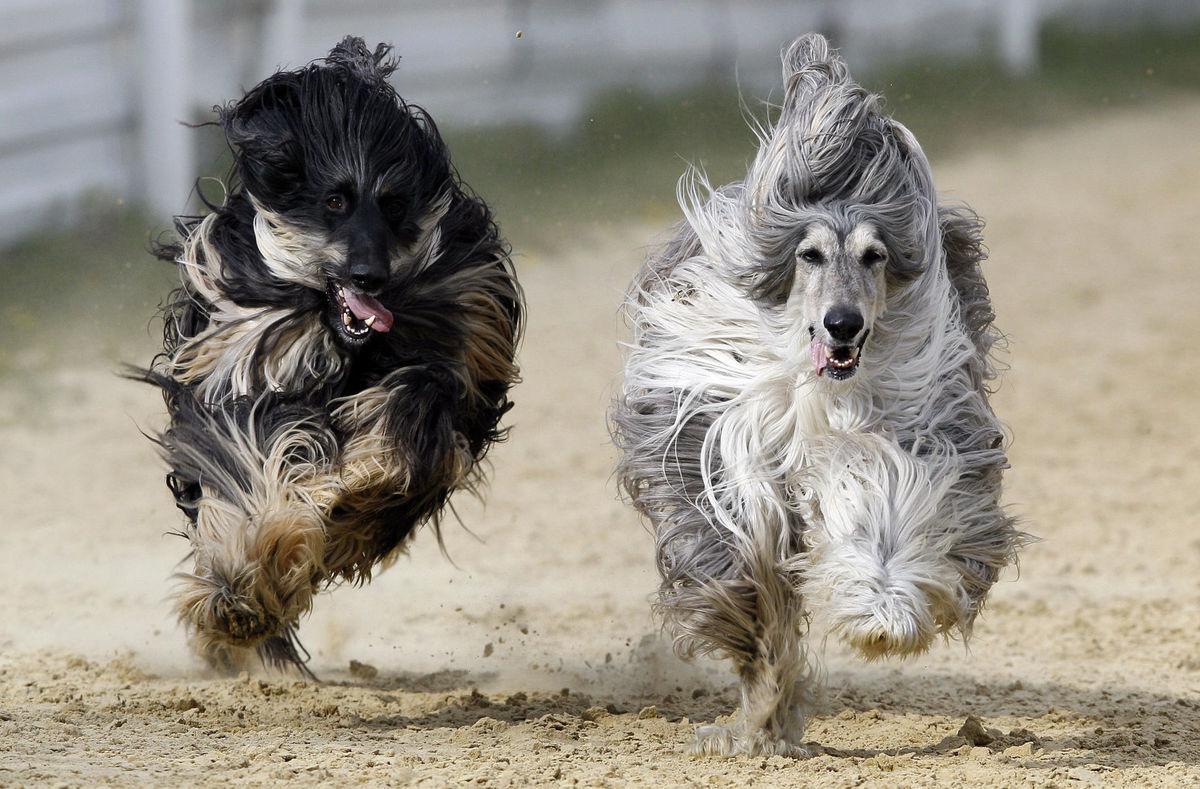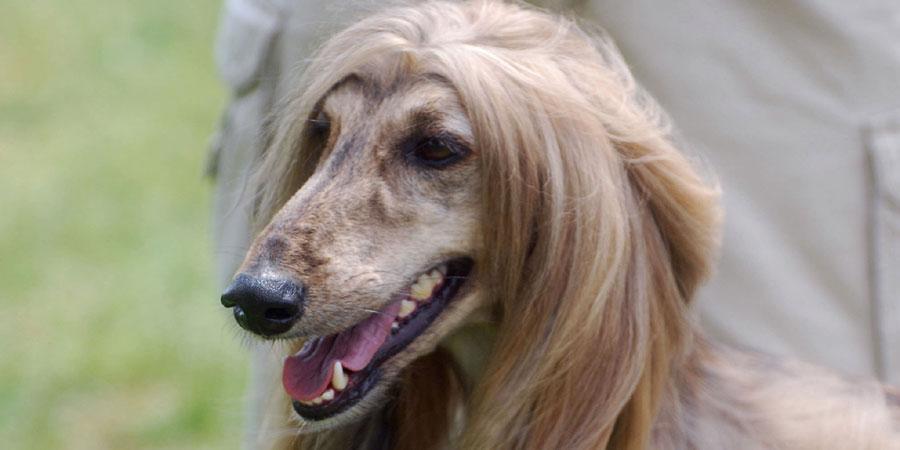The first image is the image on the left, the second image is the image on the right. Given the left and right images, does the statement "The left and right image contains the same number of dogs." hold true? Answer yes or no. No. The first image is the image on the left, the second image is the image on the right. Examine the images to the left and right. Is the description "There are four dogs in total." accurate? Answer yes or no. No. 